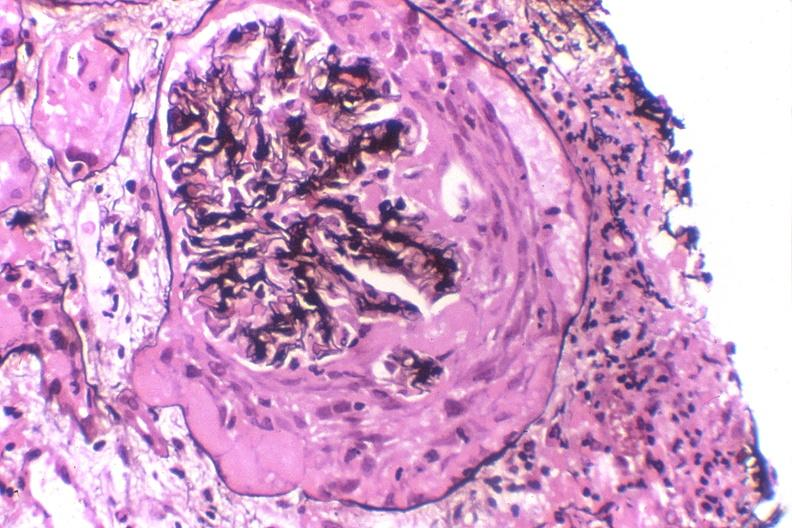where is this?
Answer the question using a single word or phrase. Urinary 